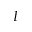Convert formula to latex. <formula><loc_0><loc_0><loc_500><loc_500>I</formula> 